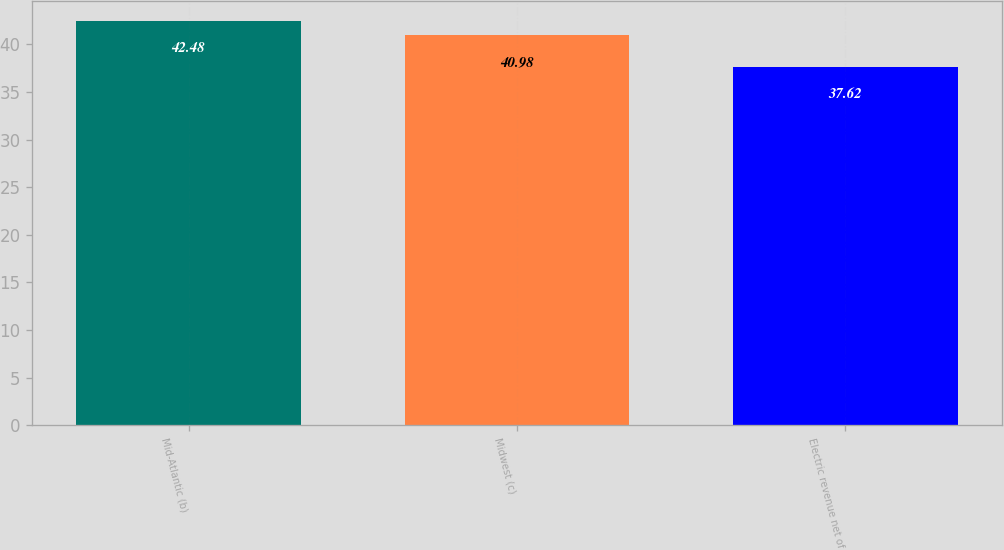<chart> <loc_0><loc_0><loc_500><loc_500><bar_chart><fcel>Mid-Atlantic (b)<fcel>Midwest (c)<fcel>Electric revenue net of<nl><fcel>42.48<fcel>40.98<fcel>37.62<nl></chart> 